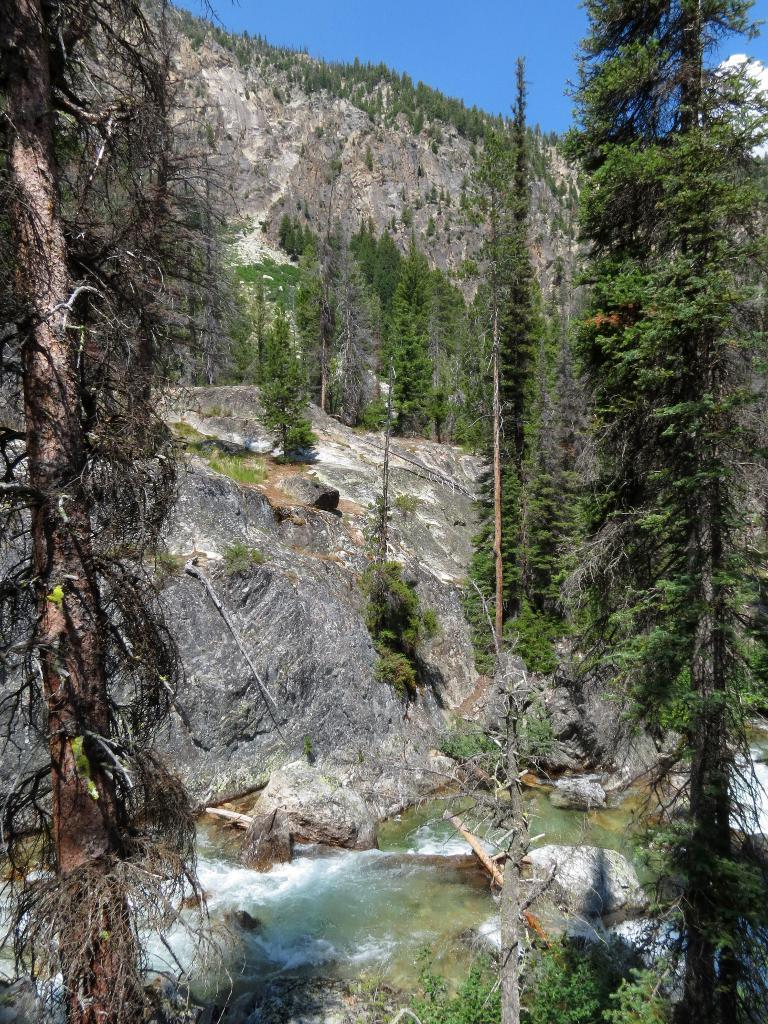What type of natural landscape is depicted in the image? The image features mountains, trees, and plants. Can you describe the water visible at the bottom of the image? There is water visible at the bottom of the image. What other types of vegetation can be seen in the image? In addition to trees, there are plants visible in the image. What territory does the sister claim in the image? There is no mention of a sister or any territorial claims in the image. 